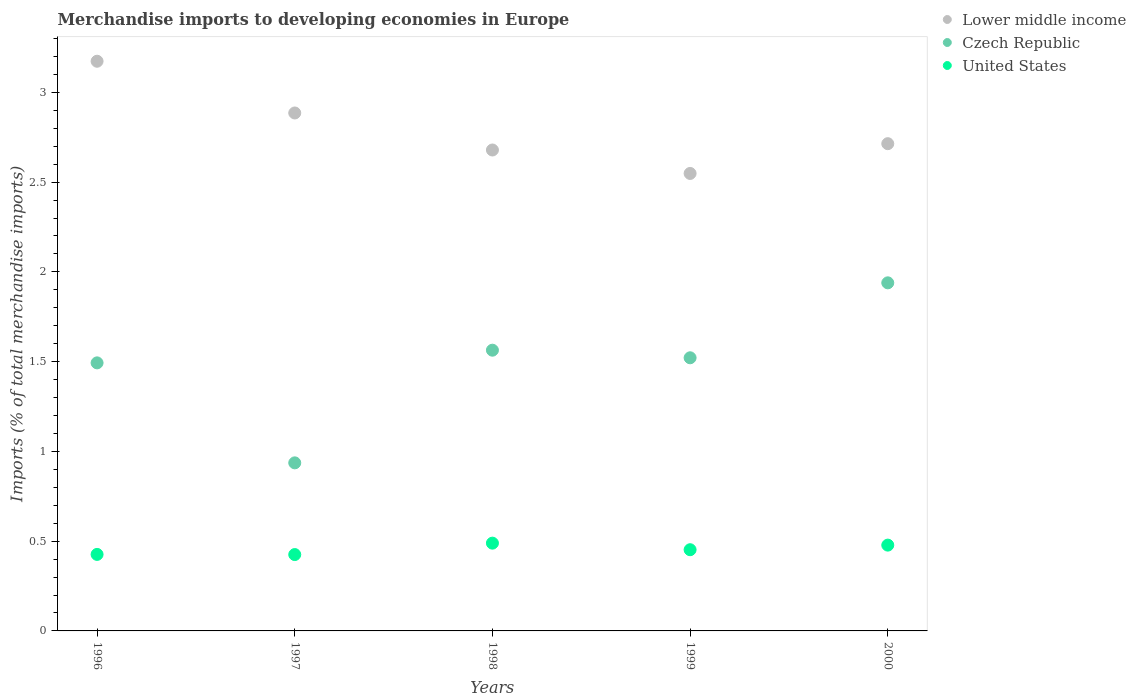How many different coloured dotlines are there?
Your answer should be very brief. 3. Is the number of dotlines equal to the number of legend labels?
Offer a terse response. Yes. What is the percentage total merchandise imports in Lower middle income in 2000?
Make the answer very short. 2.71. Across all years, what is the maximum percentage total merchandise imports in Czech Republic?
Your response must be concise. 1.94. Across all years, what is the minimum percentage total merchandise imports in Czech Republic?
Your response must be concise. 0.94. In which year was the percentage total merchandise imports in Lower middle income minimum?
Offer a terse response. 1999. What is the total percentage total merchandise imports in Lower middle income in the graph?
Your response must be concise. 14. What is the difference between the percentage total merchandise imports in Czech Republic in 1999 and that in 2000?
Keep it short and to the point. -0.42. What is the difference between the percentage total merchandise imports in Lower middle income in 1997 and the percentage total merchandise imports in United States in 2000?
Give a very brief answer. 2.41. What is the average percentage total merchandise imports in Czech Republic per year?
Your answer should be compact. 1.49. In the year 1996, what is the difference between the percentage total merchandise imports in Czech Republic and percentage total merchandise imports in Lower middle income?
Provide a short and direct response. -1.68. In how many years, is the percentage total merchandise imports in Lower middle income greater than 2.1 %?
Offer a terse response. 5. What is the ratio of the percentage total merchandise imports in Lower middle income in 1998 to that in 1999?
Your answer should be compact. 1.05. What is the difference between the highest and the second highest percentage total merchandise imports in Czech Republic?
Keep it short and to the point. 0.38. What is the difference between the highest and the lowest percentage total merchandise imports in Czech Republic?
Provide a succinct answer. 1. Is the sum of the percentage total merchandise imports in Czech Republic in 1997 and 2000 greater than the maximum percentage total merchandise imports in Lower middle income across all years?
Give a very brief answer. No. Does the percentage total merchandise imports in Lower middle income monotonically increase over the years?
Give a very brief answer. No. How many dotlines are there?
Your response must be concise. 3. Does the graph contain any zero values?
Your answer should be compact. No. What is the title of the graph?
Provide a short and direct response. Merchandise imports to developing economies in Europe. Does "Greenland" appear as one of the legend labels in the graph?
Keep it short and to the point. No. What is the label or title of the X-axis?
Offer a terse response. Years. What is the label or title of the Y-axis?
Make the answer very short. Imports (% of total merchandise imports). What is the Imports (% of total merchandise imports) of Lower middle income in 1996?
Keep it short and to the point. 3.17. What is the Imports (% of total merchandise imports) in Czech Republic in 1996?
Keep it short and to the point. 1.49. What is the Imports (% of total merchandise imports) in United States in 1996?
Your answer should be very brief. 0.43. What is the Imports (% of total merchandise imports) in Lower middle income in 1997?
Make the answer very short. 2.89. What is the Imports (% of total merchandise imports) in Czech Republic in 1997?
Ensure brevity in your answer.  0.94. What is the Imports (% of total merchandise imports) in United States in 1997?
Make the answer very short. 0.43. What is the Imports (% of total merchandise imports) in Lower middle income in 1998?
Keep it short and to the point. 2.68. What is the Imports (% of total merchandise imports) of Czech Republic in 1998?
Offer a very short reply. 1.56. What is the Imports (% of total merchandise imports) in United States in 1998?
Provide a short and direct response. 0.49. What is the Imports (% of total merchandise imports) of Lower middle income in 1999?
Give a very brief answer. 2.55. What is the Imports (% of total merchandise imports) in Czech Republic in 1999?
Offer a terse response. 1.52. What is the Imports (% of total merchandise imports) in United States in 1999?
Ensure brevity in your answer.  0.45. What is the Imports (% of total merchandise imports) in Lower middle income in 2000?
Offer a terse response. 2.71. What is the Imports (% of total merchandise imports) in Czech Republic in 2000?
Provide a succinct answer. 1.94. What is the Imports (% of total merchandise imports) in United States in 2000?
Ensure brevity in your answer.  0.48. Across all years, what is the maximum Imports (% of total merchandise imports) of Lower middle income?
Make the answer very short. 3.17. Across all years, what is the maximum Imports (% of total merchandise imports) in Czech Republic?
Offer a terse response. 1.94. Across all years, what is the maximum Imports (% of total merchandise imports) in United States?
Keep it short and to the point. 0.49. Across all years, what is the minimum Imports (% of total merchandise imports) in Lower middle income?
Provide a succinct answer. 2.55. Across all years, what is the minimum Imports (% of total merchandise imports) of Czech Republic?
Your answer should be very brief. 0.94. Across all years, what is the minimum Imports (% of total merchandise imports) in United States?
Keep it short and to the point. 0.43. What is the total Imports (% of total merchandise imports) in Lower middle income in the graph?
Your response must be concise. 14. What is the total Imports (% of total merchandise imports) in Czech Republic in the graph?
Your answer should be compact. 7.45. What is the total Imports (% of total merchandise imports) of United States in the graph?
Offer a very short reply. 2.27. What is the difference between the Imports (% of total merchandise imports) in Lower middle income in 1996 and that in 1997?
Give a very brief answer. 0.29. What is the difference between the Imports (% of total merchandise imports) in Czech Republic in 1996 and that in 1997?
Offer a very short reply. 0.56. What is the difference between the Imports (% of total merchandise imports) in United States in 1996 and that in 1997?
Ensure brevity in your answer.  0. What is the difference between the Imports (% of total merchandise imports) of Lower middle income in 1996 and that in 1998?
Make the answer very short. 0.49. What is the difference between the Imports (% of total merchandise imports) in Czech Republic in 1996 and that in 1998?
Your answer should be very brief. -0.07. What is the difference between the Imports (% of total merchandise imports) in United States in 1996 and that in 1998?
Your answer should be very brief. -0.06. What is the difference between the Imports (% of total merchandise imports) of Lower middle income in 1996 and that in 1999?
Your answer should be compact. 0.62. What is the difference between the Imports (% of total merchandise imports) in Czech Republic in 1996 and that in 1999?
Your answer should be compact. -0.03. What is the difference between the Imports (% of total merchandise imports) of United States in 1996 and that in 1999?
Make the answer very short. -0.03. What is the difference between the Imports (% of total merchandise imports) in Lower middle income in 1996 and that in 2000?
Offer a terse response. 0.46. What is the difference between the Imports (% of total merchandise imports) in Czech Republic in 1996 and that in 2000?
Provide a short and direct response. -0.45. What is the difference between the Imports (% of total merchandise imports) of United States in 1996 and that in 2000?
Ensure brevity in your answer.  -0.05. What is the difference between the Imports (% of total merchandise imports) in Lower middle income in 1997 and that in 1998?
Your answer should be compact. 0.21. What is the difference between the Imports (% of total merchandise imports) in Czech Republic in 1997 and that in 1998?
Provide a short and direct response. -0.63. What is the difference between the Imports (% of total merchandise imports) of United States in 1997 and that in 1998?
Your response must be concise. -0.06. What is the difference between the Imports (% of total merchandise imports) of Lower middle income in 1997 and that in 1999?
Provide a succinct answer. 0.34. What is the difference between the Imports (% of total merchandise imports) in Czech Republic in 1997 and that in 1999?
Your response must be concise. -0.59. What is the difference between the Imports (% of total merchandise imports) in United States in 1997 and that in 1999?
Your answer should be compact. -0.03. What is the difference between the Imports (% of total merchandise imports) of Lower middle income in 1997 and that in 2000?
Your answer should be compact. 0.17. What is the difference between the Imports (% of total merchandise imports) of Czech Republic in 1997 and that in 2000?
Your answer should be compact. -1. What is the difference between the Imports (% of total merchandise imports) in United States in 1997 and that in 2000?
Your answer should be very brief. -0.05. What is the difference between the Imports (% of total merchandise imports) of Lower middle income in 1998 and that in 1999?
Keep it short and to the point. 0.13. What is the difference between the Imports (% of total merchandise imports) of Czech Republic in 1998 and that in 1999?
Your answer should be compact. 0.04. What is the difference between the Imports (% of total merchandise imports) of United States in 1998 and that in 1999?
Offer a terse response. 0.04. What is the difference between the Imports (% of total merchandise imports) of Lower middle income in 1998 and that in 2000?
Keep it short and to the point. -0.04. What is the difference between the Imports (% of total merchandise imports) in Czech Republic in 1998 and that in 2000?
Offer a terse response. -0.38. What is the difference between the Imports (% of total merchandise imports) of United States in 1998 and that in 2000?
Provide a succinct answer. 0.01. What is the difference between the Imports (% of total merchandise imports) in Lower middle income in 1999 and that in 2000?
Provide a short and direct response. -0.17. What is the difference between the Imports (% of total merchandise imports) in Czech Republic in 1999 and that in 2000?
Provide a succinct answer. -0.42. What is the difference between the Imports (% of total merchandise imports) of United States in 1999 and that in 2000?
Offer a terse response. -0.03. What is the difference between the Imports (% of total merchandise imports) of Lower middle income in 1996 and the Imports (% of total merchandise imports) of Czech Republic in 1997?
Provide a succinct answer. 2.24. What is the difference between the Imports (% of total merchandise imports) in Lower middle income in 1996 and the Imports (% of total merchandise imports) in United States in 1997?
Offer a very short reply. 2.75. What is the difference between the Imports (% of total merchandise imports) of Czech Republic in 1996 and the Imports (% of total merchandise imports) of United States in 1997?
Provide a succinct answer. 1.07. What is the difference between the Imports (% of total merchandise imports) in Lower middle income in 1996 and the Imports (% of total merchandise imports) in Czech Republic in 1998?
Keep it short and to the point. 1.61. What is the difference between the Imports (% of total merchandise imports) in Lower middle income in 1996 and the Imports (% of total merchandise imports) in United States in 1998?
Offer a terse response. 2.68. What is the difference between the Imports (% of total merchandise imports) in Lower middle income in 1996 and the Imports (% of total merchandise imports) in Czech Republic in 1999?
Make the answer very short. 1.65. What is the difference between the Imports (% of total merchandise imports) of Lower middle income in 1996 and the Imports (% of total merchandise imports) of United States in 1999?
Provide a succinct answer. 2.72. What is the difference between the Imports (% of total merchandise imports) of Czech Republic in 1996 and the Imports (% of total merchandise imports) of United States in 1999?
Ensure brevity in your answer.  1.04. What is the difference between the Imports (% of total merchandise imports) of Lower middle income in 1996 and the Imports (% of total merchandise imports) of Czech Republic in 2000?
Your response must be concise. 1.23. What is the difference between the Imports (% of total merchandise imports) of Lower middle income in 1996 and the Imports (% of total merchandise imports) of United States in 2000?
Give a very brief answer. 2.7. What is the difference between the Imports (% of total merchandise imports) in Czech Republic in 1996 and the Imports (% of total merchandise imports) in United States in 2000?
Your response must be concise. 1.02. What is the difference between the Imports (% of total merchandise imports) in Lower middle income in 1997 and the Imports (% of total merchandise imports) in Czech Republic in 1998?
Your answer should be compact. 1.32. What is the difference between the Imports (% of total merchandise imports) in Lower middle income in 1997 and the Imports (% of total merchandise imports) in United States in 1998?
Your response must be concise. 2.4. What is the difference between the Imports (% of total merchandise imports) in Czech Republic in 1997 and the Imports (% of total merchandise imports) in United States in 1998?
Offer a very short reply. 0.45. What is the difference between the Imports (% of total merchandise imports) in Lower middle income in 1997 and the Imports (% of total merchandise imports) in Czech Republic in 1999?
Provide a succinct answer. 1.36. What is the difference between the Imports (% of total merchandise imports) of Lower middle income in 1997 and the Imports (% of total merchandise imports) of United States in 1999?
Ensure brevity in your answer.  2.43. What is the difference between the Imports (% of total merchandise imports) in Czech Republic in 1997 and the Imports (% of total merchandise imports) in United States in 1999?
Ensure brevity in your answer.  0.48. What is the difference between the Imports (% of total merchandise imports) of Lower middle income in 1997 and the Imports (% of total merchandise imports) of Czech Republic in 2000?
Ensure brevity in your answer.  0.95. What is the difference between the Imports (% of total merchandise imports) in Lower middle income in 1997 and the Imports (% of total merchandise imports) in United States in 2000?
Make the answer very short. 2.41. What is the difference between the Imports (% of total merchandise imports) of Czech Republic in 1997 and the Imports (% of total merchandise imports) of United States in 2000?
Your answer should be very brief. 0.46. What is the difference between the Imports (% of total merchandise imports) of Lower middle income in 1998 and the Imports (% of total merchandise imports) of Czech Republic in 1999?
Offer a terse response. 1.16. What is the difference between the Imports (% of total merchandise imports) in Lower middle income in 1998 and the Imports (% of total merchandise imports) in United States in 1999?
Ensure brevity in your answer.  2.23. What is the difference between the Imports (% of total merchandise imports) of Czech Republic in 1998 and the Imports (% of total merchandise imports) of United States in 1999?
Provide a succinct answer. 1.11. What is the difference between the Imports (% of total merchandise imports) of Lower middle income in 1998 and the Imports (% of total merchandise imports) of Czech Republic in 2000?
Give a very brief answer. 0.74. What is the difference between the Imports (% of total merchandise imports) in Lower middle income in 1998 and the Imports (% of total merchandise imports) in United States in 2000?
Give a very brief answer. 2.2. What is the difference between the Imports (% of total merchandise imports) of Czech Republic in 1998 and the Imports (% of total merchandise imports) of United States in 2000?
Your response must be concise. 1.09. What is the difference between the Imports (% of total merchandise imports) of Lower middle income in 1999 and the Imports (% of total merchandise imports) of Czech Republic in 2000?
Offer a very short reply. 0.61. What is the difference between the Imports (% of total merchandise imports) in Lower middle income in 1999 and the Imports (% of total merchandise imports) in United States in 2000?
Ensure brevity in your answer.  2.07. What is the difference between the Imports (% of total merchandise imports) of Czech Republic in 1999 and the Imports (% of total merchandise imports) of United States in 2000?
Your answer should be compact. 1.04. What is the average Imports (% of total merchandise imports) of Lower middle income per year?
Provide a succinct answer. 2.8. What is the average Imports (% of total merchandise imports) of Czech Republic per year?
Offer a terse response. 1.49. What is the average Imports (% of total merchandise imports) of United States per year?
Provide a short and direct response. 0.45. In the year 1996, what is the difference between the Imports (% of total merchandise imports) of Lower middle income and Imports (% of total merchandise imports) of Czech Republic?
Your response must be concise. 1.68. In the year 1996, what is the difference between the Imports (% of total merchandise imports) of Lower middle income and Imports (% of total merchandise imports) of United States?
Give a very brief answer. 2.75. In the year 1996, what is the difference between the Imports (% of total merchandise imports) of Czech Republic and Imports (% of total merchandise imports) of United States?
Provide a succinct answer. 1.07. In the year 1997, what is the difference between the Imports (% of total merchandise imports) in Lower middle income and Imports (% of total merchandise imports) in Czech Republic?
Give a very brief answer. 1.95. In the year 1997, what is the difference between the Imports (% of total merchandise imports) in Lower middle income and Imports (% of total merchandise imports) in United States?
Ensure brevity in your answer.  2.46. In the year 1997, what is the difference between the Imports (% of total merchandise imports) of Czech Republic and Imports (% of total merchandise imports) of United States?
Ensure brevity in your answer.  0.51. In the year 1998, what is the difference between the Imports (% of total merchandise imports) in Lower middle income and Imports (% of total merchandise imports) in Czech Republic?
Your answer should be very brief. 1.12. In the year 1998, what is the difference between the Imports (% of total merchandise imports) in Lower middle income and Imports (% of total merchandise imports) in United States?
Your answer should be very brief. 2.19. In the year 1998, what is the difference between the Imports (% of total merchandise imports) in Czech Republic and Imports (% of total merchandise imports) in United States?
Offer a very short reply. 1.07. In the year 1999, what is the difference between the Imports (% of total merchandise imports) in Lower middle income and Imports (% of total merchandise imports) in Czech Republic?
Keep it short and to the point. 1.03. In the year 1999, what is the difference between the Imports (% of total merchandise imports) of Lower middle income and Imports (% of total merchandise imports) of United States?
Offer a terse response. 2.1. In the year 1999, what is the difference between the Imports (% of total merchandise imports) of Czech Republic and Imports (% of total merchandise imports) of United States?
Make the answer very short. 1.07. In the year 2000, what is the difference between the Imports (% of total merchandise imports) in Lower middle income and Imports (% of total merchandise imports) in Czech Republic?
Your response must be concise. 0.78. In the year 2000, what is the difference between the Imports (% of total merchandise imports) in Lower middle income and Imports (% of total merchandise imports) in United States?
Your response must be concise. 2.24. In the year 2000, what is the difference between the Imports (% of total merchandise imports) of Czech Republic and Imports (% of total merchandise imports) of United States?
Ensure brevity in your answer.  1.46. What is the ratio of the Imports (% of total merchandise imports) of Lower middle income in 1996 to that in 1997?
Offer a terse response. 1.1. What is the ratio of the Imports (% of total merchandise imports) of Czech Republic in 1996 to that in 1997?
Ensure brevity in your answer.  1.59. What is the ratio of the Imports (% of total merchandise imports) in Lower middle income in 1996 to that in 1998?
Offer a very short reply. 1.18. What is the ratio of the Imports (% of total merchandise imports) in Czech Republic in 1996 to that in 1998?
Make the answer very short. 0.95. What is the ratio of the Imports (% of total merchandise imports) in United States in 1996 to that in 1998?
Ensure brevity in your answer.  0.87. What is the ratio of the Imports (% of total merchandise imports) in Lower middle income in 1996 to that in 1999?
Your answer should be compact. 1.25. What is the ratio of the Imports (% of total merchandise imports) of Czech Republic in 1996 to that in 1999?
Ensure brevity in your answer.  0.98. What is the ratio of the Imports (% of total merchandise imports) in United States in 1996 to that in 1999?
Offer a very short reply. 0.94. What is the ratio of the Imports (% of total merchandise imports) of Lower middle income in 1996 to that in 2000?
Offer a very short reply. 1.17. What is the ratio of the Imports (% of total merchandise imports) of Czech Republic in 1996 to that in 2000?
Your answer should be compact. 0.77. What is the ratio of the Imports (% of total merchandise imports) in United States in 1996 to that in 2000?
Provide a succinct answer. 0.89. What is the ratio of the Imports (% of total merchandise imports) of Lower middle income in 1997 to that in 1998?
Keep it short and to the point. 1.08. What is the ratio of the Imports (% of total merchandise imports) in Czech Republic in 1997 to that in 1998?
Make the answer very short. 0.6. What is the ratio of the Imports (% of total merchandise imports) of United States in 1997 to that in 1998?
Make the answer very short. 0.87. What is the ratio of the Imports (% of total merchandise imports) of Lower middle income in 1997 to that in 1999?
Keep it short and to the point. 1.13. What is the ratio of the Imports (% of total merchandise imports) of Czech Republic in 1997 to that in 1999?
Your response must be concise. 0.62. What is the ratio of the Imports (% of total merchandise imports) of United States in 1997 to that in 1999?
Your response must be concise. 0.94. What is the ratio of the Imports (% of total merchandise imports) in Lower middle income in 1997 to that in 2000?
Provide a short and direct response. 1.06. What is the ratio of the Imports (% of total merchandise imports) of Czech Republic in 1997 to that in 2000?
Your answer should be very brief. 0.48. What is the ratio of the Imports (% of total merchandise imports) in United States in 1997 to that in 2000?
Make the answer very short. 0.89. What is the ratio of the Imports (% of total merchandise imports) of Lower middle income in 1998 to that in 1999?
Make the answer very short. 1.05. What is the ratio of the Imports (% of total merchandise imports) in Czech Republic in 1998 to that in 1999?
Ensure brevity in your answer.  1.03. What is the ratio of the Imports (% of total merchandise imports) of United States in 1998 to that in 1999?
Give a very brief answer. 1.08. What is the ratio of the Imports (% of total merchandise imports) in Czech Republic in 1998 to that in 2000?
Ensure brevity in your answer.  0.81. What is the ratio of the Imports (% of total merchandise imports) in United States in 1998 to that in 2000?
Your response must be concise. 1.02. What is the ratio of the Imports (% of total merchandise imports) in Lower middle income in 1999 to that in 2000?
Your response must be concise. 0.94. What is the ratio of the Imports (% of total merchandise imports) in Czech Republic in 1999 to that in 2000?
Keep it short and to the point. 0.78. What is the ratio of the Imports (% of total merchandise imports) in United States in 1999 to that in 2000?
Ensure brevity in your answer.  0.95. What is the difference between the highest and the second highest Imports (% of total merchandise imports) of Lower middle income?
Ensure brevity in your answer.  0.29. What is the difference between the highest and the second highest Imports (% of total merchandise imports) of Czech Republic?
Make the answer very short. 0.38. What is the difference between the highest and the second highest Imports (% of total merchandise imports) of United States?
Your answer should be very brief. 0.01. What is the difference between the highest and the lowest Imports (% of total merchandise imports) of Czech Republic?
Your response must be concise. 1. What is the difference between the highest and the lowest Imports (% of total merchandise imports) in United States?
Provide a short and direct response. 0.06. 